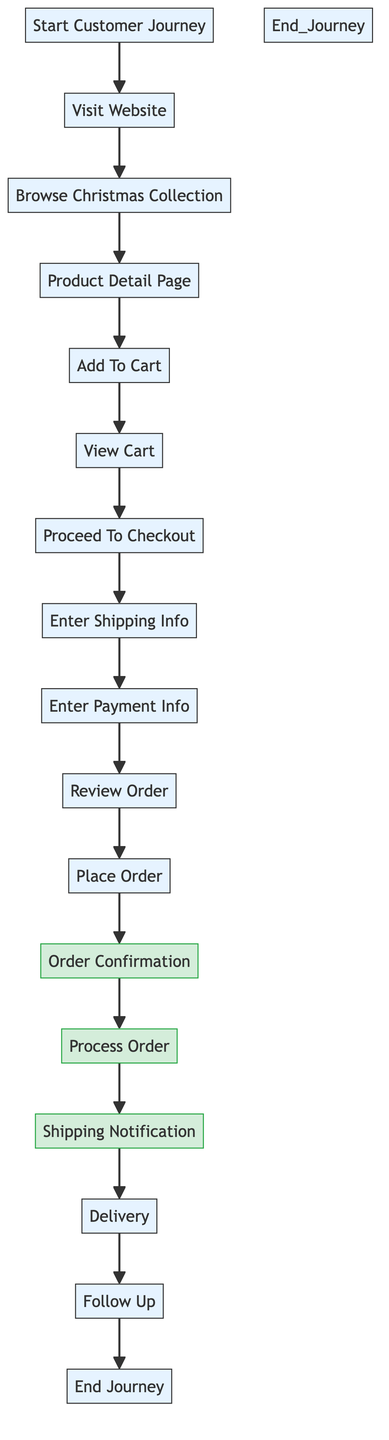What is the first step in the customer purchase journey? The first step listed in the diagram is labeled "Start Customer Journey," which indicates the beginning of the process.
Answer: Start Customer Journey How many total steps are there in the customer purchase journey? Counting all the distinct nodes in the diagram, there are 15 steps from "Start Customer Journey" to "End Journey."
Answer: 15 What follows after the customer adds an item to the cart? In the flowchart, the step "View Cart" directly follows "Add To Cart," signifying the process of reviewing selected items.
Answer: View Cart Which step comes immediately after the "Review Order" step? Following "Review Order" in the sequence of the flowchart is the step labeled "Place Order," indicating the action taken by the customer after reviewing their selections.
Answer: Place Order How many notifications are sent to the customer after the order is placed? The diagram indicates there are two notifications sent after placing the order: "Order Confirmation" and "Shipping Notification," confirming the initial order and later updates.
Answer: 2 What is the final step in the customer journey? The last node in the diagram is labeled "End Customer Journey," marking the conclusion of all purchasing activities.
Answer: End Customer Journey What is the relationship between "Enter Shipping Info" and "Enter Payment Info"? Both “Enter Shipping Info” and “Enter Payment Info” are sequential steps in the flowchart, with Enter Shipping Info leading directly to Enter Payment Info as part of the checkout process.
Answer: Sequential steps Which step includes feedback or promotions after the delivery? The step "Follow Up" is designated for sending a follow-up email to customers, aimed at gathering feedback or offering future promotions after delivery.
Answer: Follow Up What is the main purpose of the "Process Order" step? The "Process Order" step indicates the store's action in handling the customer's order post-confirmation, which is a critical operational step in fulfilling online purchases.
Answer: Handle the order 